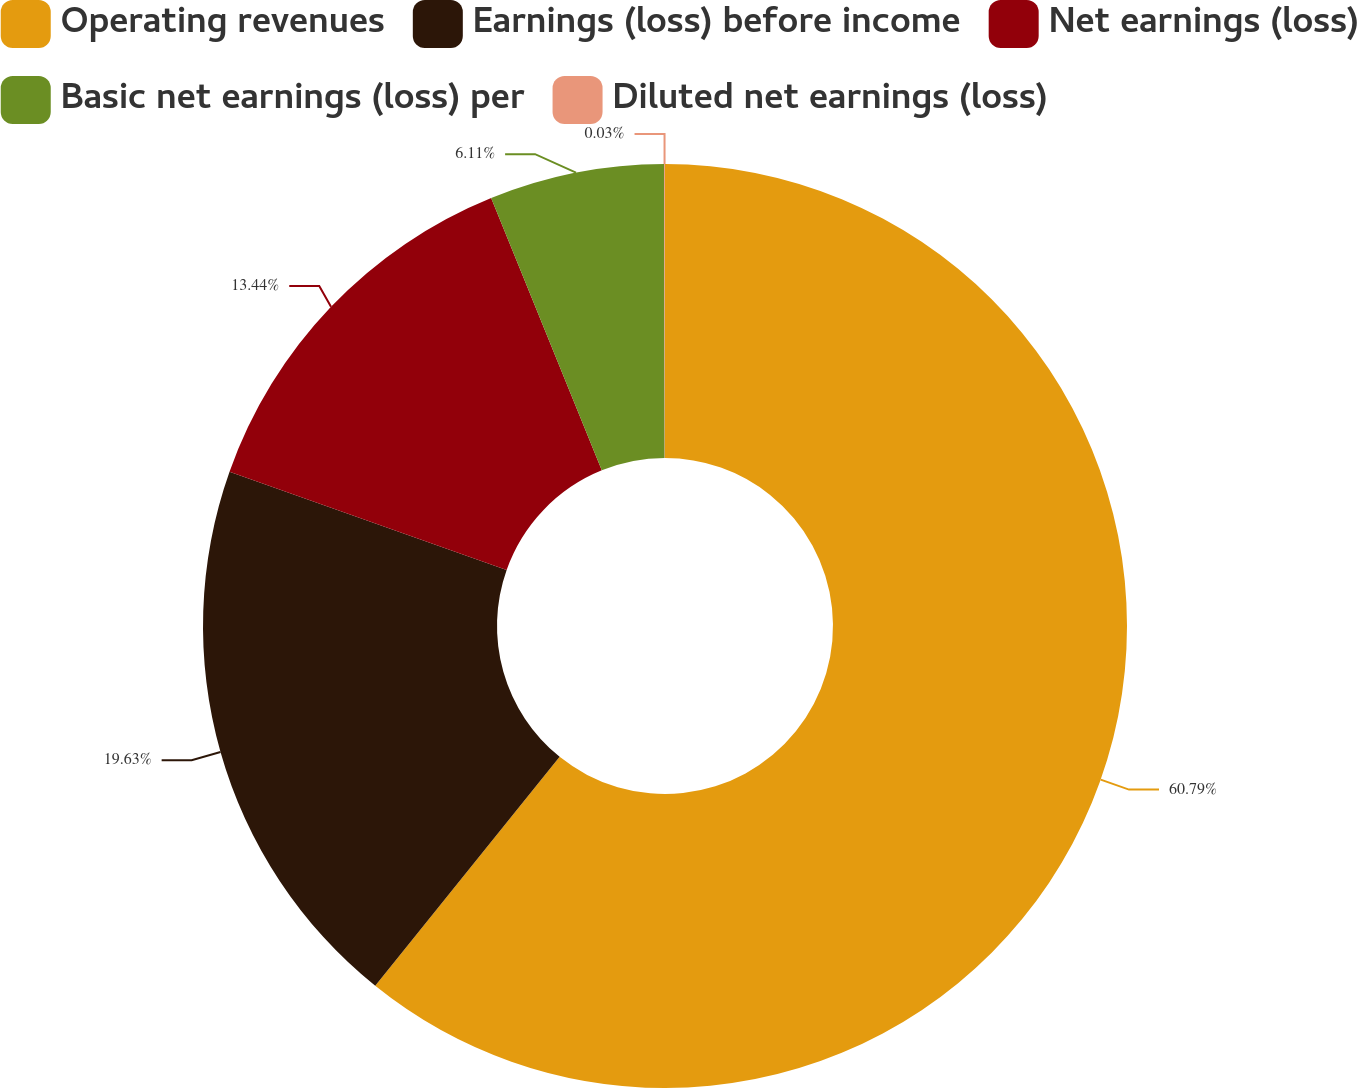<chart> <loc_0><loc_0><loc_500><loc_500><pie_chart><fcel>Operating revenues<fcel>Earnings (loss) before income<fcel>Net earnings (loss)<fcel>Basic net earnings (loss) per<fcel>Diluted net earnings (loss)<nl><fcel>60.79%<fcel>19.63%<fcel>13.44%<fcel>6.11%<fcel>0.03%<nl></chart> 